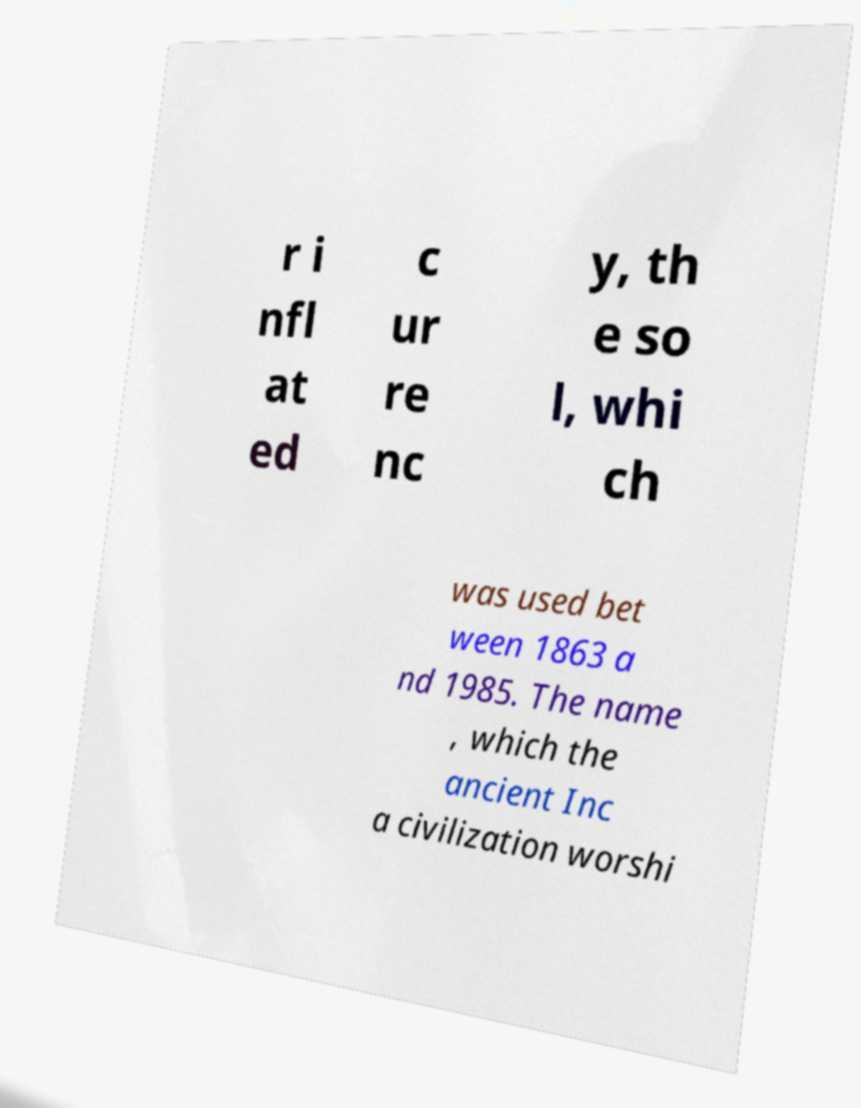Can you accurately transcribe the text from the provided image for me? r i nfl at ed c ur re nc y, th e so l, whi ch was used bet ween 1863 a nd 1985. The name , which the ancient Inc a civilization worshi 